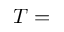<formula> <loc_0><loc_0><loc_500><loc_500>T =</formula> 